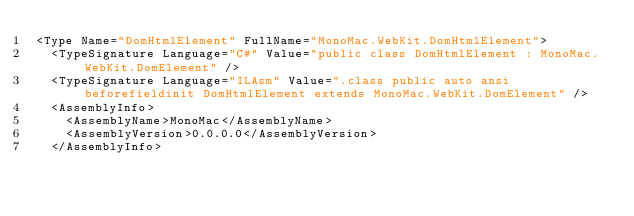Convert code to text. <code><loc_0><loc_0><loc_500><loc_500><_XML_><Type Name="DomHtmlElement" FullName="MonoMac.WebKit.DomHtmlElement">
  <TypeSignature Language="C#" Value="public class DomHtmlElement : MonoMac.WebKit.DomElement" />
  <TypeSignature Language="ILAsm" Value=".class public auto ansi beforefieldinit DomHtmlElement extends MonoMac.WebKit.DomElement" />
  <AssemblyInfo>
    <AssemblyName>MonoMac</AssemblyName>
    <AssemblyVersion>0.0.0.0</AssemblyVersion>
  </AssemblyInfo></code> 